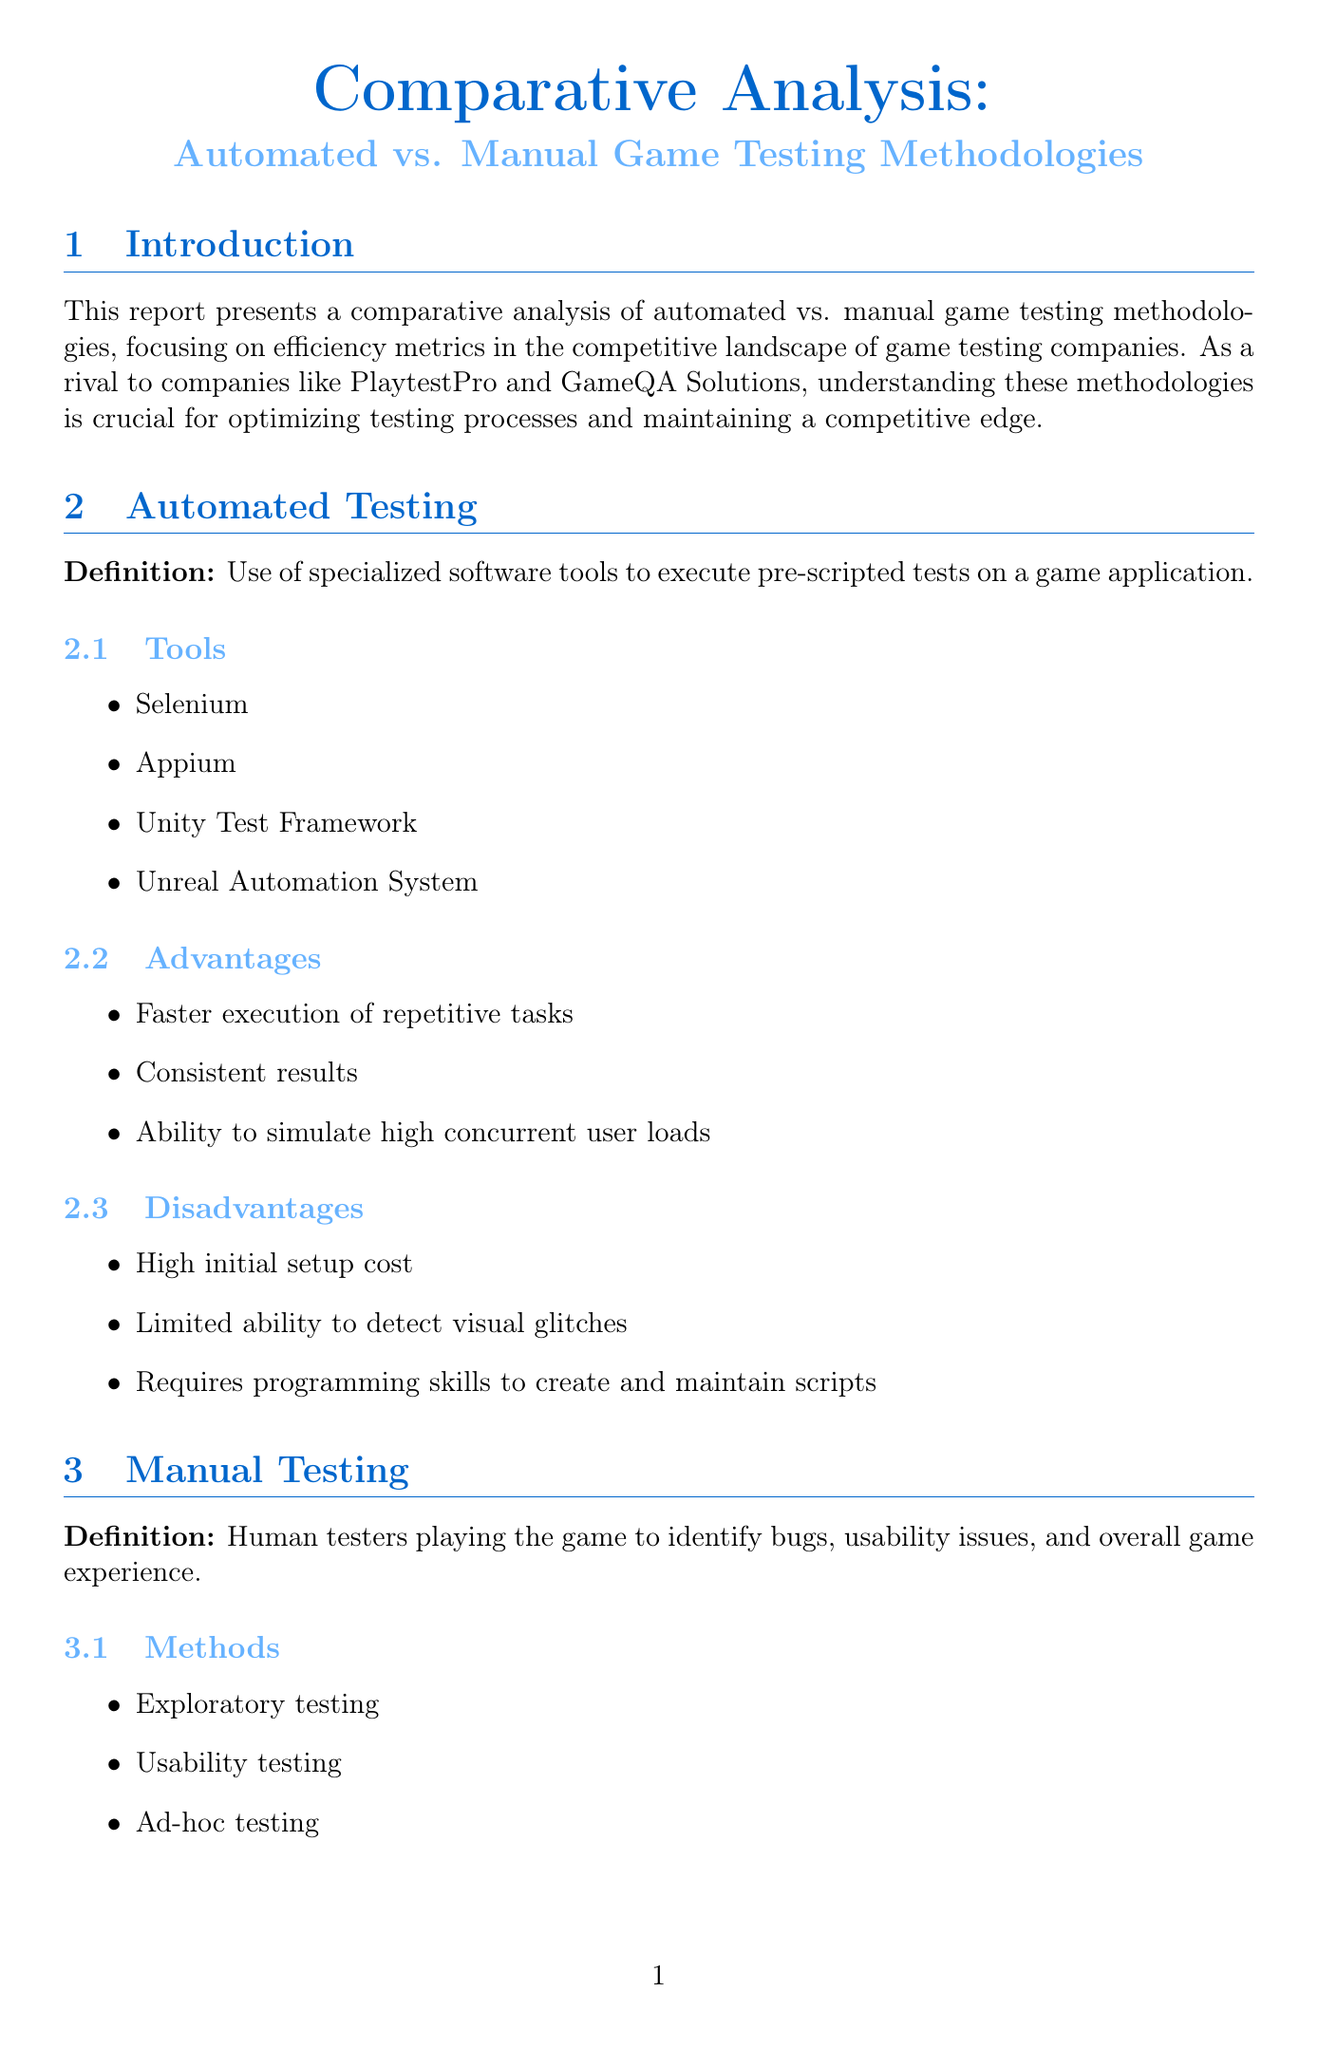what is the focus of the report? The report focuses on comparing automated and manual game testing methodologies, specifically in terms of efficiency metrics.
Answer: efficiency metrics which company conducted a hybrid testing approach for Assassin's Creed: Valhalla? The document mentions that Ubisoft used a hybrid testing approach for the game.
Answer: Ubisoft what is the time taken for an automated testing regression suite? The document states that it takes 24 hours to complete an automated testing regression suite.
Answer: 24 hours what percentage of test coverage does automated testing achieve for repetitive tasks? According to the document, automated testing achieves 80 percent test coverage for repetitive tasks.
Answer: 80% what is a disadvantage of manual testing? The document notes that a disadvantage of manual testing is that it is time-consuming for large-scale testing.
Answer: time-consuming what is one of the industry trends in game testing mentioned? The report lists AI-assisted testing as an emerging trend in the industry.
Answer: AI-assisted testing which testing method allows flexibility to adapt to changing game designs? Exploratory testing is mentioned as a method that allows flexibility in adapting to game designs.
Answer: Exploratory testing what is the cost per bug for automated testing? The document states that the average cost per bug for automated testing is fifty dollars.
Answer: fifty dollars 